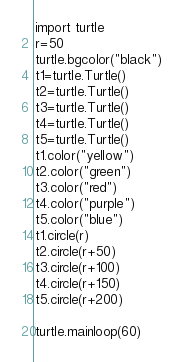<code> <loc_0><loc_0><loc_500><loc_500><_Python_>import turtle
r=50
turtle.bgcolor("black")
t1=turtle.Turtle()
t2=turtle.Turtle()
t3=turtle.Turtle()
t4=turtle.Turtle()
t5=turtle.Turtle()
t1.color("yellow")
t2.color("green")
t3.color("red")
t4.color("purple")
t5.color("blue")
t1.circle(r)
t2.circle(r+50)
t3.circle(r+100)
t4.circle(r+150)
t5.circle(r+200)

turtle.mainloop(60)
</code> 